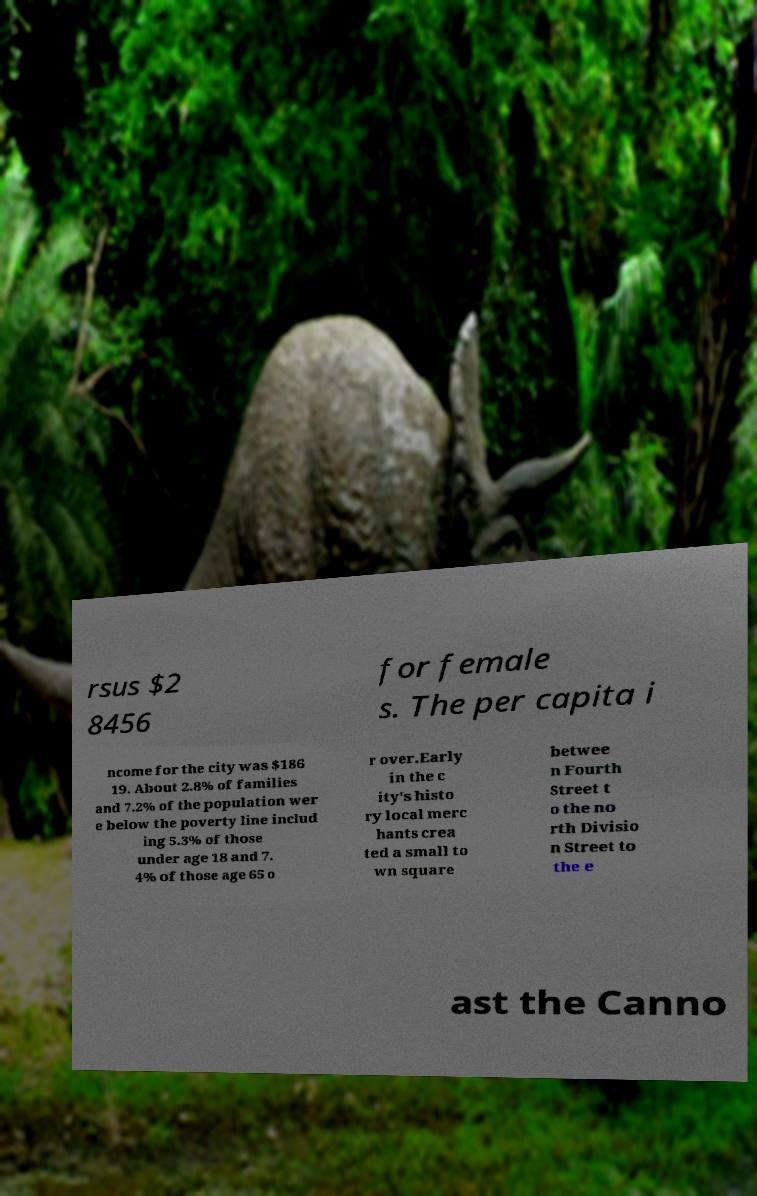What messages or text are displayed in this image? I need them in a readable, typed format. rsus $2 8456 for female s. The per capita i ncome for the city was $186 19. About 2.8% of families and 7.2% of the population wer e below the poverty line includ ing 5.3% of those under age 18 and 7. 4% of those age 65 o r over.Early in the c ity's histo ry local merc hants crea ted a small to wn square betwee n Fourth Street t o the no rth Divisio n Street to the e ast the Canno 